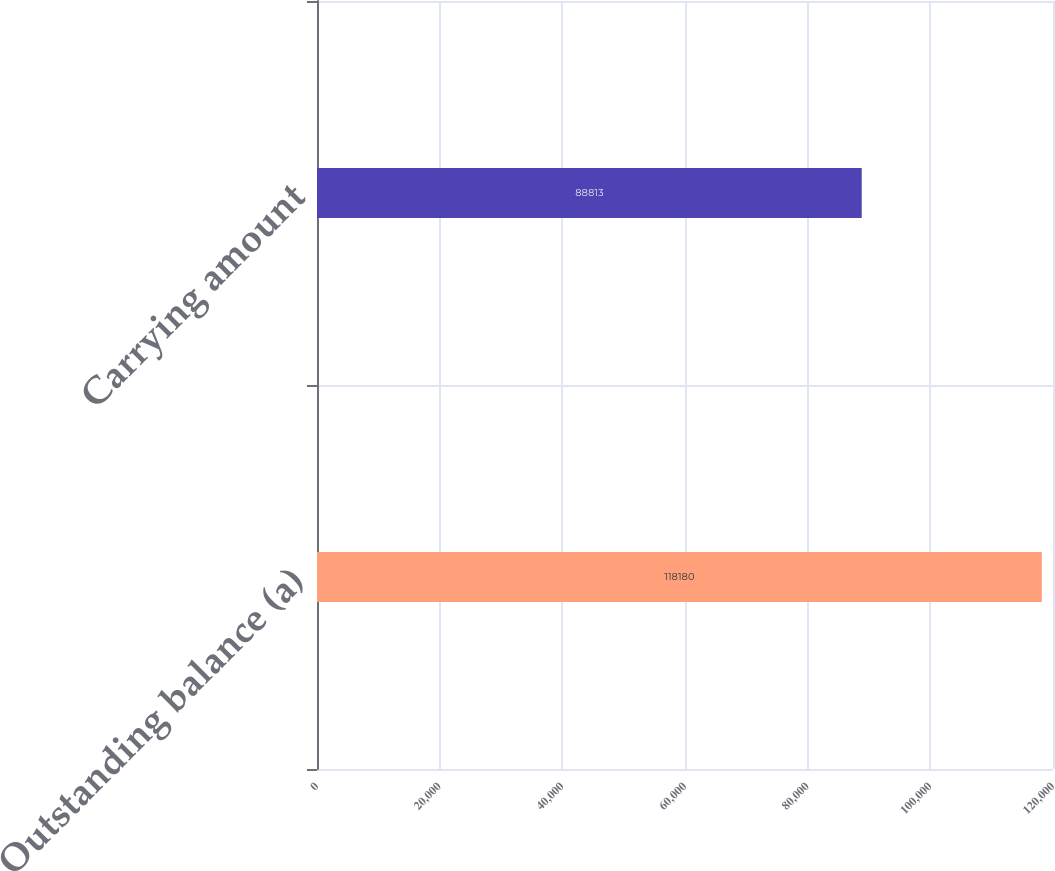Convert chart. <chart><loc_0><loc_0><loc_500><loc_500><bar_chart><fcel>Outstanding balance (a)<fcel>Carrying amount<nl><fcel>118180<fcel>88813<nl></chart> 